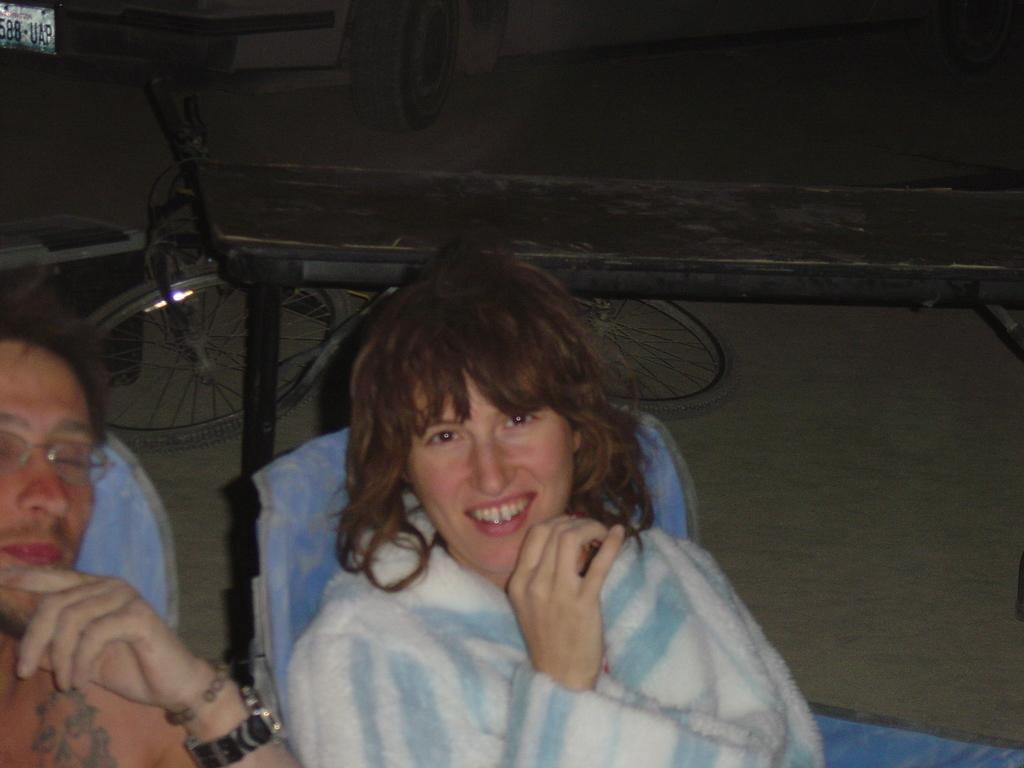How many people are sitting in the image? There are two people sitting on chairs in the image. What can be observed about the lighting in the image? The background of the image is dark. What objects can be seen in the background of the image? There is a bicycle, a vehicle, and a box in the background of the image. What type of zebra can be seen standing on top of the box in the image? There is no zebra present in the image, and therefore no such activity can be observed. 